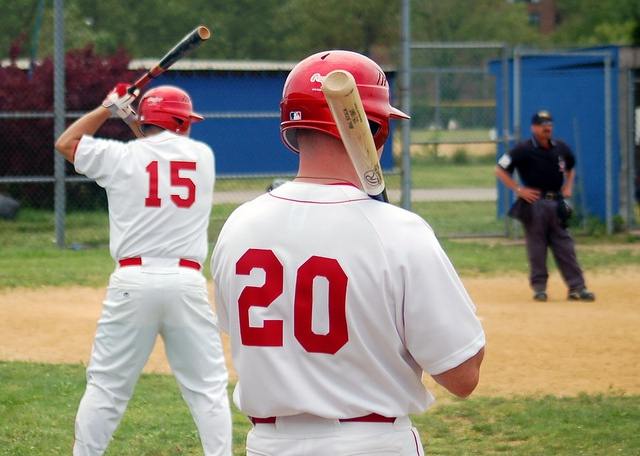Describe the objects in this image and their specific colors. I can see people in darkgreen, lightgray, darkgray, and brown tones, people in darkgreen, lightgray, darkgray, and brown tones, people in darkgreen, black, gray, maroon, and brown tones, baseball bat in darkgreen, tan, gray, and darkgray tones, and baseball bat in darkgreen, black, maroon, gray, and darkgray tones in this image. 